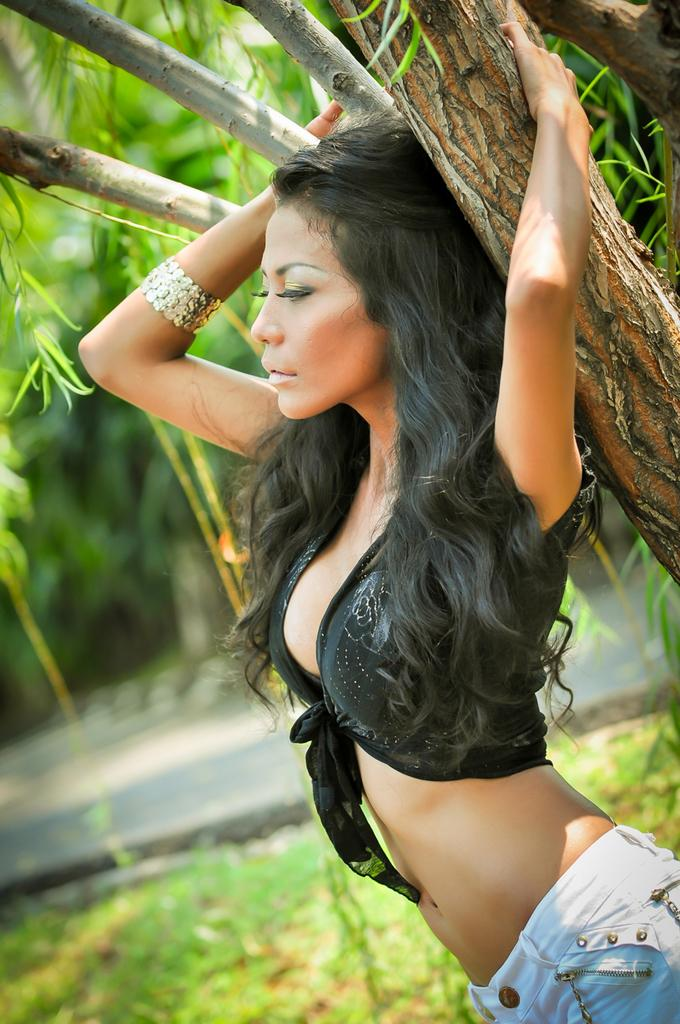What is the main subject of the image? There is a woman standing in the image. What is the woman wearing? The woman is wearing clothes and a bracelet. What type of vegetation is present in the image? There is a tree and grass in the image. How would you describe the background of the image? The background of the image is slightly blurred. What type of food does the woman's mouth show disgust for in the image? There is no indication of the woman's mouth or any food in the image, so it is not possible to determine what, if any, food she might show disgust for. 